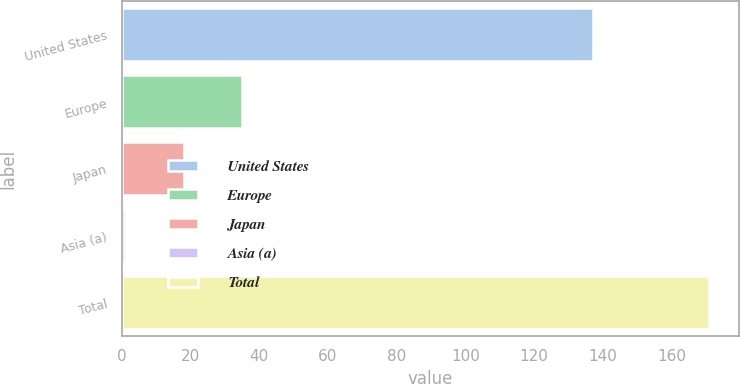Convert chart. <chart><loc_0><loc_0><loc_500><loc_500><bar_chart><fcel>United States<fcel>Europe<fcel>Japan<fcel>Asia (a)<fcel>Total<nl><fcel>137<fcel>35<fcel>18<fcel>1<fcel>171<nl></chart> 